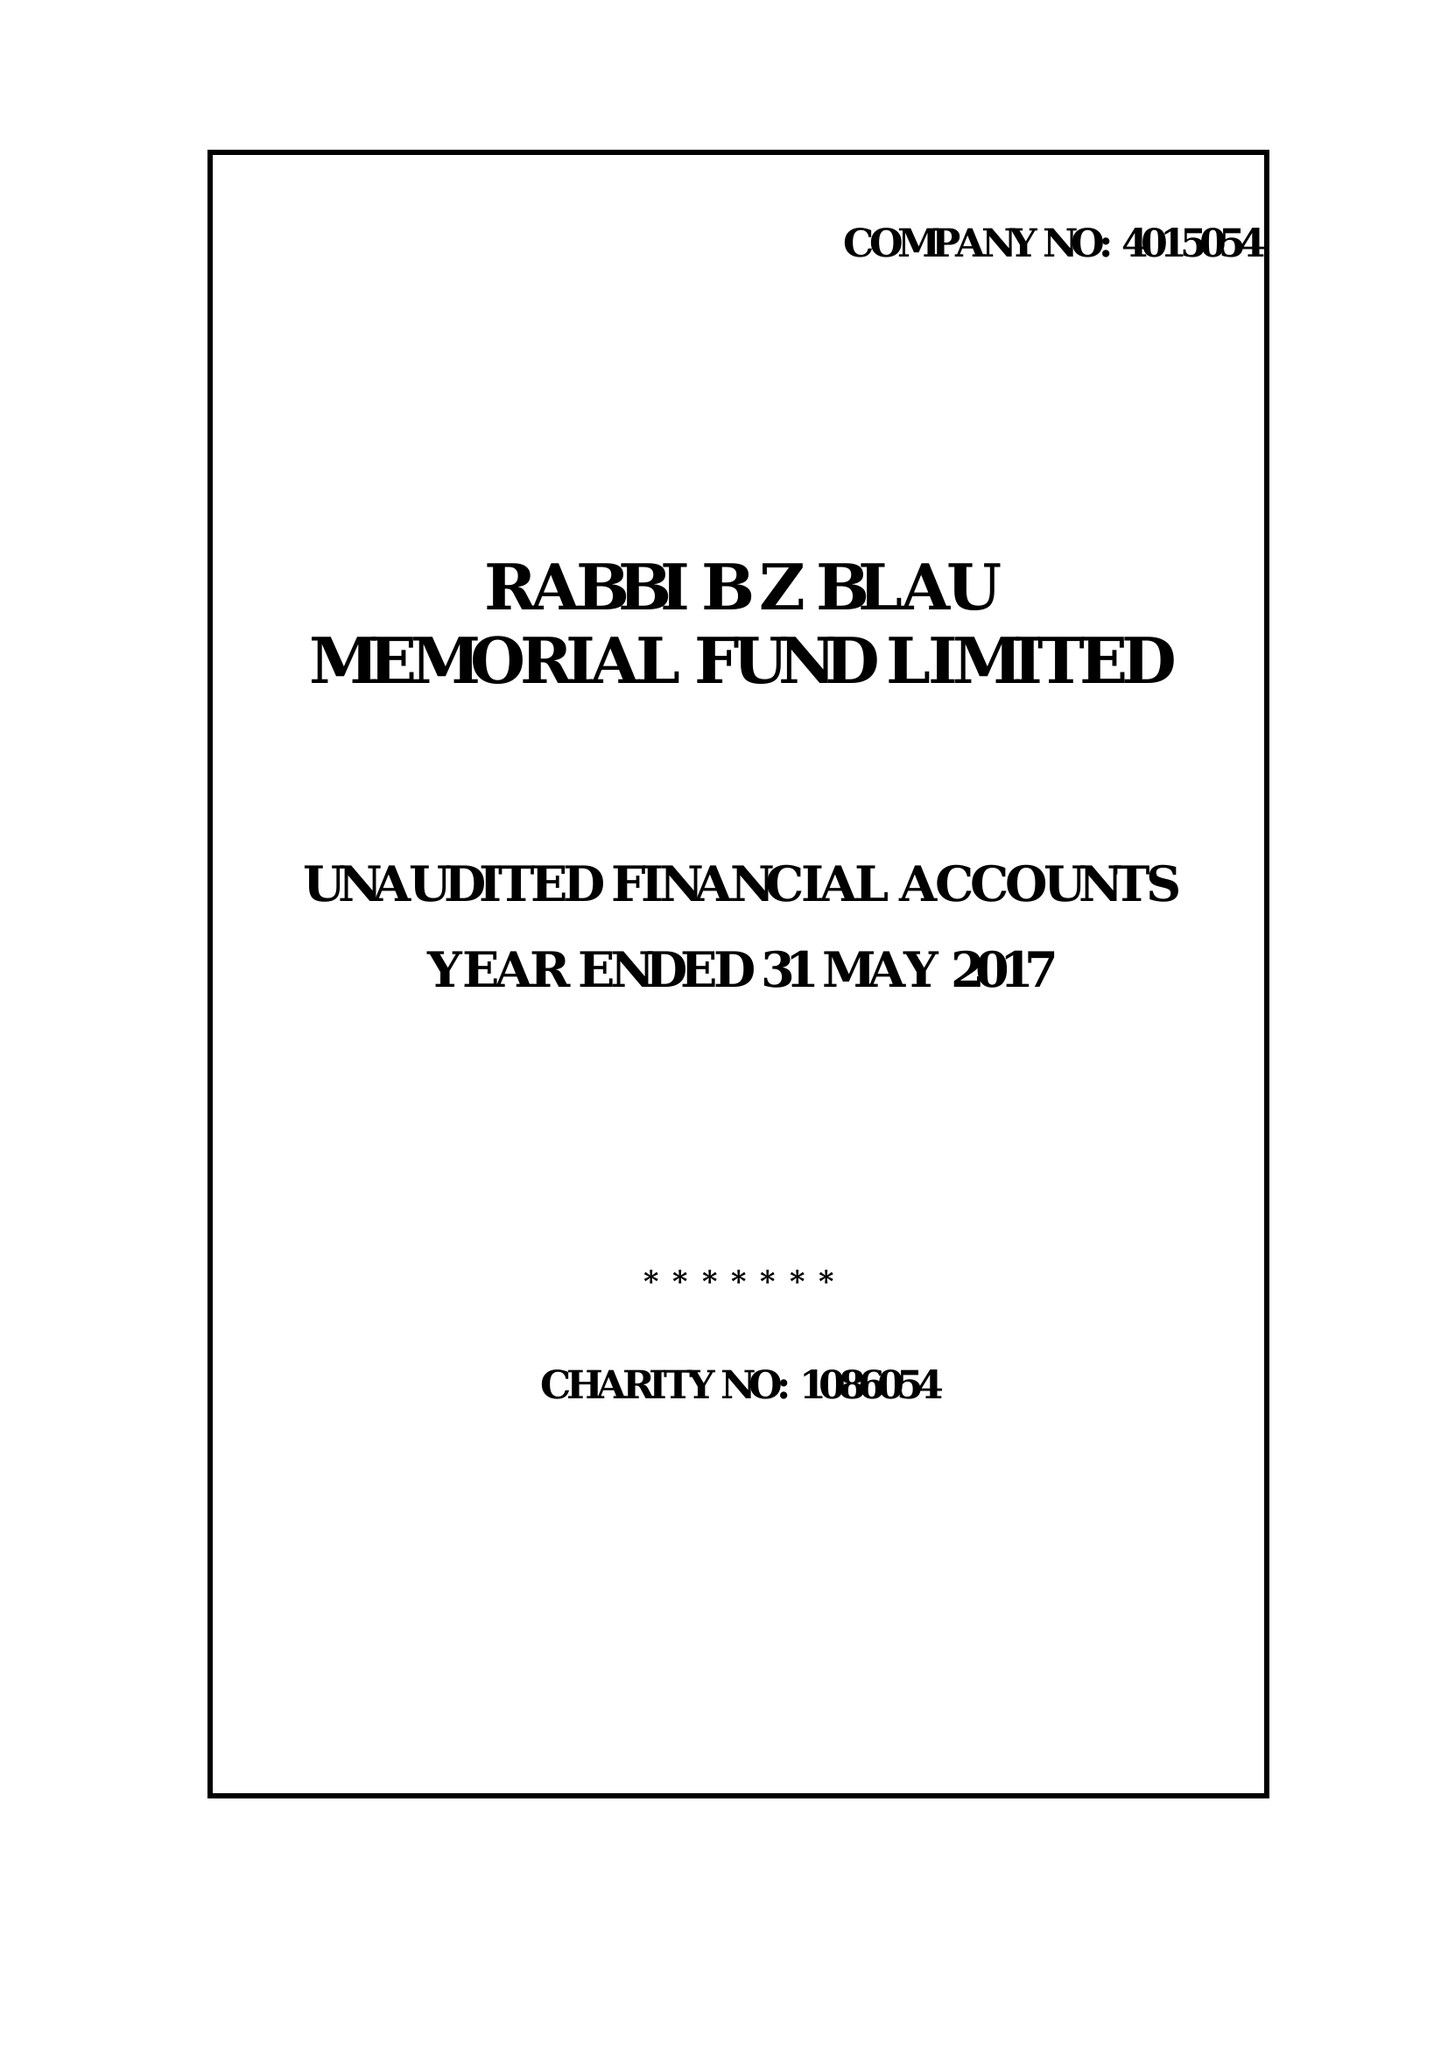What is the value for the charity_name?
Answer the question using a single word or phrase. Rabbi B Z Blau Memorial Fund Ltd. 